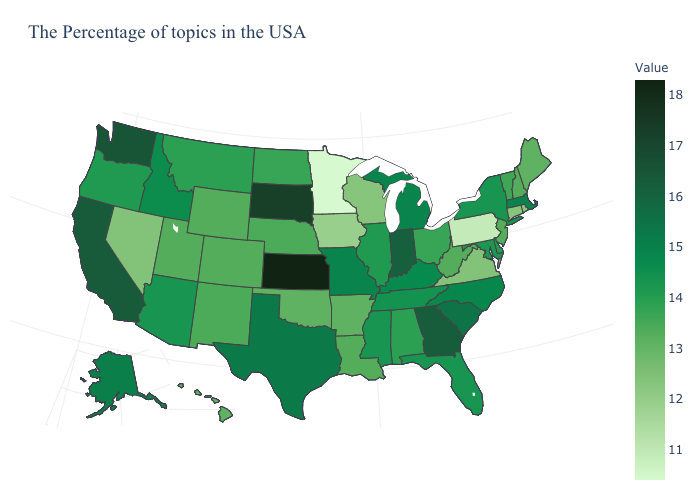Among the states that border Delaware , does Maryland have the highest value?
Concise answer only. Yes. Does Ohio have the lowest value in the MidWest?
Concise answer only. No. Does Alabama have the lowest value in the USA?
Be succinct. No. Which states hav the highest value in the South?
Keep it brief. Georgia. Does Washington have the highest value in the West?
Short answer required. Yes. 